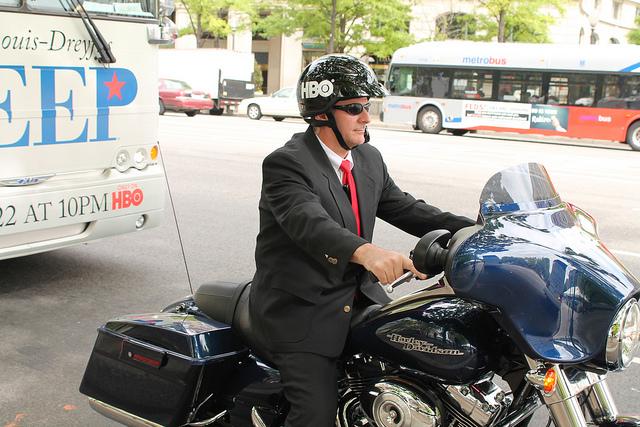What kind of pants does the seated man have on?
Short answer required. Dress. Is the motorcycle moving?
Give a very brief answer. No. Is this a business man on a motorcycle?
Answer briefly. Yes. What is the man wearing on his head?
Give a very brief answer. Helmet. What does this man's job?
Concise answer only. Hbo. Who is wearing goggles?
Keep it brief. Man. What TV station is advertised on the bus?
Be succinct. Hbo. 